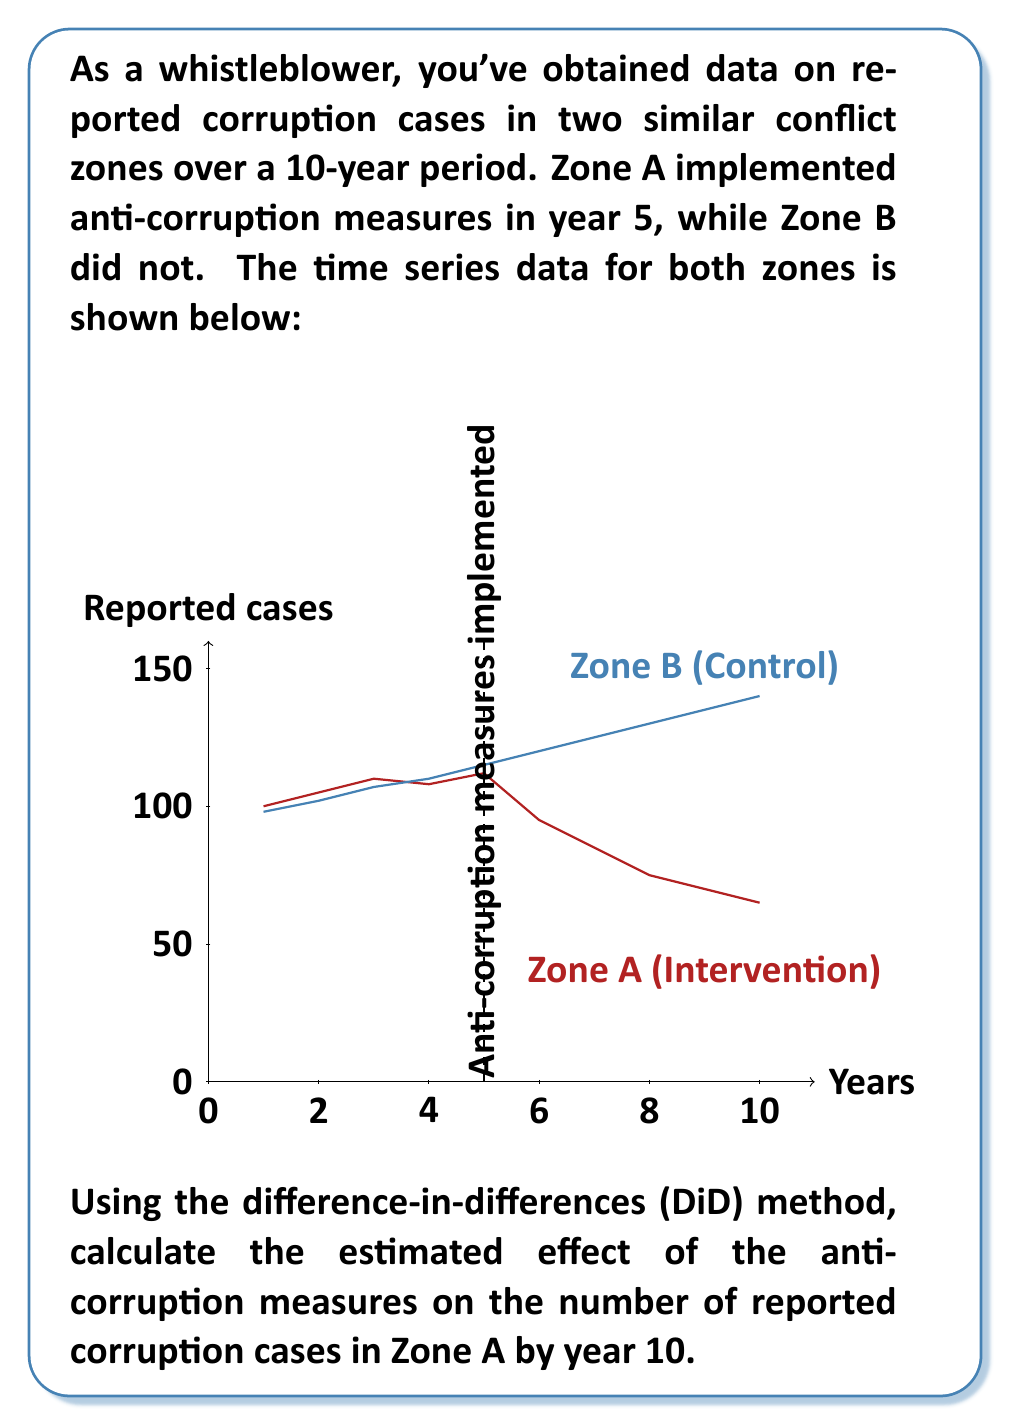Can you solve this math problem? To solve this problem using the difference-in-differences (DiD) method, we'll follow these steps:

1) Identify the pre-intervention and post-intervention periods:
   Pre-intervention: Years 1-5
   Post-intervention: Years 6-10

2) Calculate the average number of reported cases for each zone in each period:

   Zone A (Intervention):
   Pre-intervention average: $A_{pre} = \frac{100 + 105 + 110 + 108 + 112}{5} = 107$
   Post-intervention average: $A_{post} = \frac{95 + 85 + 75 + 70 + 65}{5} = 78$

   Zone B (Control):
   Pre-intervention average: $B_{pre} = \frac{98 + 102 + 107 + 110 + 115}{5} = 106.4$
   Post-intervention average: $B_{post} = \frac{120 + 125 + 130 + 135 + 140}{5} = 130$

3) Calculate the difference in each zone:
   Zone A difference: $A_{diff} = A_{post} - A_{pre} = 78 - 107 = -29$
   Zone B difference: $B_{diff} = B_{post} - B_{pre} = 130 - 106.4 = 23.6$

4) Calculate the difference-in-differences:
   $DiD = A_{diff} - B_{diff} = -29 - 23.6 = -52.6$

The DiD estimate of -52.6 represents the estimated effect of the anti-corruption measures on the number of reported corruption cases in Zone A by year 10, compared to what would have happened without the intervention (as represented by Zone B).
Answer: -52.6 cases 